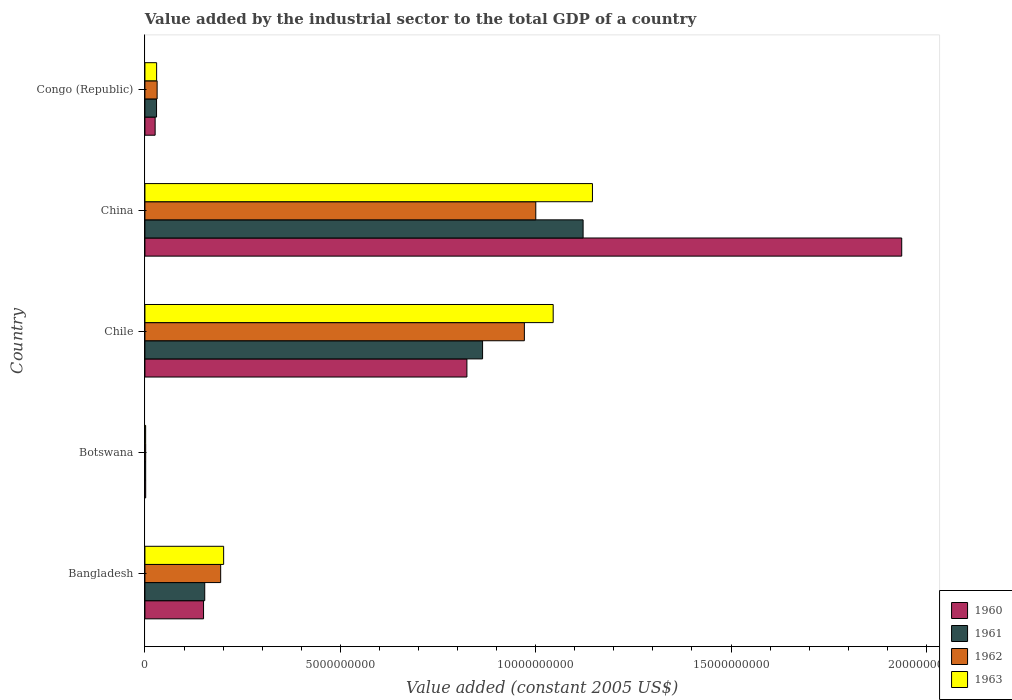Are the number of bars on each tick of the Y-axis equal?
Your response must be concise. Yes. What is the label of the 3rd group of bars from the top?
Offer a very short reply. Chile. What is the value added by the industrial sector in 1962 in China?
Make the answer very short. 1.00e+1. Across all countries, what is the maximum value added by the industrial sector in 1962?
Offer a very short reply. 1.00e+1. Across all countries, what is the minimum value added by the industrial sector in 1962?
Give a very brief answer. 1.98e+07. In which country was the value added by the industrial sector in 1960 maximum?
Your answer should be very brief. China. In which country was the value added by the industrial sector in 1962 minimum?
Give a very brief answer. Botswana. What is the total value added by the industrial sector in 1961 in the graph?
Offer a terse response. 2.17e+1. What is the difference between the value added by the industrial sector in 1961 in Bangladesh and that in Chile?
Ensure brevity in your answer.  -7.11e+09. What is the difference between the value added by the industrial sector in 1962 in Botswana and the value added by the industrial sector in 1963 in Bangladesh?
Offer a very short reply. -1.99e+09. What is the average value added by the industrial sector in 1963 per country?
Make the answer very short. 4.85e+09. What is the difference between the value added by the industrial sector in 1960 and value added by the industrial sector in 1963 in Botswana?
Provide a short and direct response. 1.27e+06. What is the ratio of the value added by the industrial sector in 1960 in Bangladesh to that in Chile?
Provide a succinct answer. 0.18. What is the difference between the highest and the second highest value added by the industrial sector in 1961?
Give a very brief answer. 2.57e+09. What is the difference between the highest and the lowest value added by the industrial sector in 1962?
Offer a terse response. 9.98e+09. What does the 1st bar from the top in Chile represents?
Keep it short and to the point. 1963. Are all the bars in the graph horizontal?
Make the answer very short. Yes. How many countries are there in the graph?
Offer a terse response. 5. How many legend labels are there?
Keep it short and to the point. 4. What is the title of the graph?
Your answer should be very brief. Value added by the industrial sector to the total GDP of a country. Does "1984" appear as one of the legend labels in the graph?
Your answer should be compact. No. What is the label or title of the X-axis?
Your answer should be very brief. Value added (constant 2005 US$). What is the label or title of the Y-axis?
Make the answer very short. Country. What is the Value added (constant 2005 US$) in 1960 in Bangladesh?
Give a very brief answer. 1.50e+09. What is the Value added (constant 2005 US$) of 1961 in Bangladesh?
Your answer should be very brief. 1.53e+09. What is the Value added (constant 2005 US$) of 1962 in Bangladesh?
Your answer should be compact. 1.94e+09. What is the Value added (constant 2005 US$) in 1963 in Bangladesh?
Provide a short and direct response. 2.01e+09. What is the Value added (constant 2005 US$) in 1960 in Botswana?
Make the answer very short. 1.96e+07. What is the Value added (constant 2005 US$) in 1961 in Botswana?
Provide a short and direct response. 1.92e+07. What is the Value added (constant 2005 US$) of 1962 in Botswana?
Make the answer very short. 1.98e+07. What is the Value added (constant 2005 US$) in 1963 in Botswana?
Ensure brevity in your answer.  1.83e+07. What is the Value added (constant 2005 US$) of 1960 in Chile?
Your answer should be compact. 8.24e+09. What is the Value added (constant 2005 US$) of 1961 in Chile?
Provide a succinct answer. 8.64e+09. What is the Value added (constant 2005 US$) in 1962 in Chile?
Your response must be concise. 9.71e+09. What is the Value added (constant 2005 US$) of 1963 in Chile?
Your response must be concise. 1.04e+1. What is the Value added (constant 2005 US$) in 1960 in China?
Offer a terse response. 1.94e+1. What is the Value added (constant 2005 US$) of 1961 in China?
Your answer should be compact. 1.12e+1. What is the Value added (constant 2005 US$) in 1962 in China?
Give a very brief answer. 1.00e+1. What is the Value added (constant 2005 US$) of 1963 in China?
Give a very brief answer. 1.15e+1. What is the Value added (constant 2005 US$) of 1960 in Congo (Republic)?
Your response must be concise. 2.61e+08. What is the Value added (constant 2005 US$) of 1961 in Congo (Republic)?
Your answer should be very brief. 2.98e+08. What is the Value added (constant 2005 US$) of 1962 in Congo (Republic)?
Keep it short and to the point. 3.12e+08. What is the Value added (constant 2005 US$) in 1963 in Congo (Republic)?
Keep it short and to the point. 3.00e+08. Across all countries, what is the maximum Value added (constant 2005 US$) in 1960?
Offer a terse response. 1.94e+1. Across all countries, what is the maximum Value added (constant 2005 US$) in 1961?
Offer a very short reply. 1.12e+1. Across all countries, what is the maximum Value added (constant 2005 US$) of 1962?
Ensure brevity in your answer.  1.00e+1. Across all countries, what is the maximum Value added (constant 2005 US$) in 1963?
Make the answer very short. 1.15e+1. Across all countries, what is the minimum Value added (constant 2005 US$) of 1960?
Your answer should be compact. 1.96e+07. Across all countries, what is the minimum Value added (constant 2005 US$) of 1961?
Keep it short and to the point. 1.92e+07. Across all countries, what is the minimum Value added (constant 2005 US$) of 1962?
Provide a short and direct response. 1.98e+07. Across all countries, what is the minimum Value added (constant 2005 US$) in 1963?
Your response must be concise. 1.83e+07. What is the total Value added (constant 2005 US$) of 1960 in the graph?
Your answer should be very brief. 2.94e+1. What is the total Value added (constant 2005 US$) in 1961 in the graph?
Provide a succinct answer. 2.17e+1. What is the total Value added (constant 2005 US$) in 1962 in the graph?
Provide a short and direct response. 2.20e+1. What is the total Value added (constant 2005 US$) of 1963 in the graph?
Offer a terse response. 2.42e+1. What is the difference between the Value added (constant 2005 US$) of 1960 in Bangladesh and that in Botswana?
Your answer should be very brief. 1.48e+09. What is the difference between the Value added (constant 2005 US$) in 1961 in Bangladesh and that in Botswana?
Make the answer very short. 1.51e+09. What is the difference between the Value added (constant 2005 US$) in 1962 in Bangladesh and that in Botswana?
Provide a short and direct response. 1.92e+09. What is the difference between the Value added (constant 2005 US$) of 1963 in Bangladesh and that in Botswana?
Give a very brief answer. 2.00e+09. What is the difference between the Value added (constant 2005 US$) in 1960 in Bangladesh and that in Chile?
Provide a short and direct response. -6.74e+09. What is the difference between the Value added (constant 2005 US$) of 1961 in Bangladesh and that in Chile?
Your answer should be very brief. -7.11e+09. What is the difference between the Value added (constant 2005 US$) of 1962 in Bangladesh and that in Chile?
Keep it short and to the point. -7.77e+09. What is the difference between the Value added (constant 2005 US$) in 1963 in Bangladesh and that in Chile?
Offer a very short reply. -8.43e+09. What is the difference between the Value added (constant 2005 US$) of 1960 in Bangladesh and that in China?
Make the answer very short. -1.79e+1. What is the difference between the Value added (constant 2005 US$) of 1961 in Bangladesh and that in China?
Offer a very short reply. -9.68e+09. What is the difference between the Value added (constant 2005 US$) in 1962 in Bangladesh and that in China?
Provide a succinct answer. -8.06e+09. What is the difference between the Value added (constant 2005 US$) in 1963 in Bangladesh and that in China?
Give a very brief answer. -9.44e+09. What is the difference between the Value added (constant 2005 US$) of 1960 in Bangladesh and that in Congo (Republic)?
Your answer should be compact. 1.24e+09. What is the difference between the Value added (constant 2005 US$) of 1961 in Bangladesh and that in Congo (Republic)?
Your response must be concise. 1.23e+09. What is the difference between the Value added (constant 2005 US$) in 1962 in Bangladesh and that in Congo (Republic)?
Your answer should be compact. 1.63e+09. What is the difference between the Value added (constant 2005 US$) of 1963 in Bangladesh and that in Congo (Republic)?
Your answer should be very brief. 1.71e+09. What is the difference between the Value added (constant 2005 US$) in 1960 in Botswana and that in Chile?
Provide a succinct answer. -8.22e+09. What is the difference between the Value added (constant 2005 US$) of 1961 in Botswana and that in Chile?
Provide a short and direct response. -8.62e+09. What is the difference between the Value added (constant 2005 US$) of 1962 in Botswana and that in Chile?
Provide a short and direct response. -9.69e+09. What is the difference between the Value added (constant 2005 US$) in 1963 in Botswana and that in Chile?
Your response must be concise. -1.04e+1. What is the difference between the Value added (constant 2005 US$) in 1960 in Botswana and that in China?
Make the answer very short. -1.93e+1. What is the difference between the Value added (constant 2005 US$) in 1961 in Botswana and that in China?
Provide a short and direct response. -1.12e+1. What is the difference between the Value added (constant 2005 US$) in 1962 in Botswana and that in China?
Ensure brevity in your answer.  -9.98e+09. What is the difference between the Value added (constant 2005 US$) of 1963 in Botswana and that in China?
Provide a succinct answer. -1.14e+1. What is the difference between the Value added (constant 2005 US$) of 1960 in Botswana and that in Congo (Republic)?
Provide a succinct answer. -2.42e+08. What is the difference between the Value added (constant 2005 US$) in 1961 in Botswana and that in Congo (Republic)?
Give a very brief answer. -2.78e+08. What is the difference between the Value added (constant 2005 US$) in 1962 in Botswana and that in Congo (Republic)?
Offer a terse response. -2.93e+08. What is the difference between the Value added (constant 2005 US$) of 1963 in Botswana and that in Congo (Republic)?
Offer a very short reply. -2.81e+08. What is the difference between the Value added (constant 2005 US$) in 1960 in Chile and that in China?
Offer a terse response. -1.11e+1. What is the difference between the Value added (constant 2005 US$) in 1961 in Chile and that in China?
Provide a succinct answer. -2.57e+09. What is the difference between the Value added (constant 2005 US$) in 1962 in Chile and that in China?
Offer a terse response. -2.92e+08. What is the difference between the Value added (constant 2005 US$) of 1963 in Chile and that in China?
Your answer should be very brief. -1.01e+09. What is the difference between the Value added (constant 2005 US$) in 1960 in Chile and that in Congo (Republic)?
Provide a succinct answer. 7.98e+09. What is the difference between the Value added (constant 2005 US$) of 1961 in Chile and that in Congo (Republic)?
Your answer should be very brief. 8.34e+09. What is the difference between the Value added (constant 2005 US$) of 1962 in Chile and that in Congo (Republic)?
Your response must be concise. 9.40e+09. What is the difference between the Value added (constant 2005 US$) of 1963 in Chile and that in Congo (Republic)?
Provide a succinct answer. 1.01e+1. What is the difference between the Value added (constant 2005 US$) in 1960 in China and that in Congo (Republic)?
Provide a succinct answer. 1.91e+1. What is the difference between the Value added (constant 2005 US$) in 1961 in China and that in Congo (Republic)?
Offer a terse response. 1.09e+1. What is the difference between the Value added (constant 2005 US$) of 1962 in China and that in Congo (Republic)?
Provide a succinct answer. 9.69e+09. What is the difference between the Value added (constant 2005 US$) of 1963 in China and that in Congo (Republic)?
Ensure brevity in your answer.  1.12e+1. What is the difference between the Value added (constant 2005 US$) of 1960 in Bangladesh and the Value added (constant 2005 US$) of 1961 in Botswana?
Give a very brief answer. 1.48e+09. What is the difference between the Value added (constant 2005 US$) in 1960 in Bangladesh and the Value added (constant 2005 US$) in 1962 in Botswana?
Provide a short and direct response. 1.48e+09. What is the difference between the Value added (constant 2005 US$) in 1960 in Bangladesh and the Value added (constant 2005 US$) in 1963 in Botswana?
Offer a very short reply. 1.48e+09. What is the difference between the Value added (constant 2005 US$) in 1961 in Bangladesh and the Value added (constant 2005 US$) in 1962 in Botswana?
Your answer should be compact. 1.51e+09. What is the difference between the Value added (constant 2005 US$) in 1961 in Bangladesh and the Value added (constant 2005 US$) in 1963 in Botswana?
Ensure brevity in your answer.  1.51e+09. What is the difference between the Value added (constant 2005 US$) of 1962 in Bangladesh and the Value added (constant 2005 US$) of 1963 in Botswana?
Your answer should be compact. 1.92e+09. What is the difference between the Value added (constant 2005 US$) in 1960 in Bangladesh and the Value added (constant 2005 US$) in 1961 in Chile?
Your answer should be very brief. -7.14e+09. What is the difference between the Value added (constant 2005 US$) in 1960 in Bangladesh and the Value added (constant 2005 US$) in 1962 in Chile?
Offer a terse response. -8.21e+09. What is the difference between the Value added (constant 2005 US$) in 1960 in Bangladesh and the Value added (constant 2005 US$) in 1963 in Chile?
Provide a succinct answer. -8.95e+09. What is the difference between the Value added (constant 2005 US$) in 1961 in Bangladesh and the Value added (constant 2005 US$) in 1962 in Chile?
Provide a succinct answer. -8.18e+09. What is the difference between the Value added (constant 2005 US$) in 1961 in Bangladesh and the Value added (constant 2005 US$) in 1963 in Chile?
Ensure brevity in your answer.  -8.92e+09. What is the difference between the Value added (constant 2005 US$) in 1962 in Bangladesh and the Value added (constant 2005 US$) in 1963 in Chile?
Keep it short and to the point. -8.51e+09. What is the difference between the Value added (constant 2005 US$) of 1960 in Bangladesh and the Value added (constant 2005 US$) of 1961 in China?
Give a very brief answer. -9.71e+09. What is the difference between the Value added (constant 2005 US$) of 1960 in Bangladesh and the Value added (constant 2005 US$) of 1962 in China?
Make the answer very short. -8.50e+09. What is the difference between the Value added (constant 2005 US$) of 1960 in Bangladesh and the Value added (constant 2005 US$) of 1963 in China?
Offer a terse response. -9.95e+09. What is the difference between the Value added (constant 2005 US$) in 1961 in Bangladesh and the Value added (constant 2005 US$) in 1962 in China?
Ensure brevity in your answer.  -8.47e+09. What is the difference between the Value added (constant 2005 US$) of 1961 in Bangladesh and the Value added (constant 2005 US$) of 1963 in China?
Give a very brief answer. -9.92e+09. What is the difference between the Value added (constant 2005 US$) in 1962 in Bangladesh and the Value added (constant 2005 US$) in 1963 in China?
Keep it short and to the point. -9.51e+09. What is the difference between the Value added (constant 2005 US$) in 1960 in Bangladesh and the Value added (constant 2005 US$) in 1961 in Congo (Republic)?
Your answer should be very brief. 1.20e+09. What is the difference between the Value added (constant 2005 US$) of 1960 in Bangladesh and the Value added (constant 2005 US$) of 1962 in Congo (Republic)?
Your answer should be compact. 1.19e+09. What is the difference between the Value added (constant 2005 US$) of 1960 in Bangladesh and the Value added (constant 2005 US$) of 1963 in Congo (Republic)?
Your response must be concise. 1.20e+09. What is the difference between the Value added (constant 2005 US$) of 1961 in Bangladesh and the Value added (constant 2005 US$) of 1962 in Congo (Republic)?
Your answer should be compact. 1.22e+09. What is the difference between the Value added (constant 2005 US$) of 1961 in Bangladesh and the Value added (constant 2005 US$) of 1963 in Congo (Republic)?
Give a very brief answer. 1.23e+09. What is the difference between the Value added (constant 2005 US$) in 1962 in Bangladesh and the Value added (constant 2005 US$) in 1963 in Congo (Republic)?
Keep it short and to the point. 1.64e+09. What is the difference between the Value added (constant 2005 US$) of 1960 in Botswana and the Value added (constant 2005 US$) of 1961 in Chile?
Your answer should be compact. -8.62e+09. What is the difference between the Value added (constant 2005 US$) in 1960 in Botswana and the Value added (constant 2005 US$) in 1962 in Chile?
Your answer should be compact. -9.69e+09. What is the difference between the Value added (constant 2005 US$) in 1960 in Botswana and the Value added (constant 2005 US$) in 1963 in Chile?
Make the answer very short. -1.04e+1. What is the difference between the Value added (constant 2005 US$) in 1961 in Botswana and the Value added (constant 2005 US$) in 1962 in Chile?
Ensure brevity in your answer.  -9.69e+09. What is the difference between the Value added (constant 2005 US$) of 1961 in Botswana and the Value added (constant 2005 US$) of 1963 in Chile?
Your answer should be very brief. -1.04e+1. What is the difference between the Value added (constant 2005 US$) of 1962 in Botswana and the Value added (constant 2005 US$) of 1963 in Chile?
Give a very brief answer. -1.04e+1. What is the difference between the Value added (constant 2005 US$) in 1960 in Botswana and the Value added (constant 2005 US$) in 1961 in China?
Offer a very short reply. -1.12e+1. What is the difference between the Value added (constant 2005 US$) of 1960 in Botswana and the Value added (constant 2005 US$) of 1962 in China?
Provide a succinct answer. -9.98e+09. What is the difference between the Value added (constant 2005 US$) of 1960 in Botswana and the Value added (constant 2005 US$) of 1963 in China?
Offer a very short reply. -1.14e+1. What is the difference between the Value added (constant 2005 US$) of 1961 in Botswana and the Value added (constant 2005 US$) of 1962 in China?
Your answer should be very brief. -9.98e+09. What is the difference between the Value added (constant 2005 US$) in 1961 in Botswana and the Value added (constant 2005 US$) in 1963 in China?
Offer a terse response. -1.14e+1. What is the difference between the Value added (constant 2005 US$) in 1962 in Botswana and the Value added (constant 2005 US$) in 1963 in China?
Give a very brief answer. -1.14e+1. What is the difference between the Value added (constant 2005 US$) in 1960 in Botswana and the Value added (constant 2005 US$) in 1961 in Congo (Republic)?
Provide a short and direct response. -2.78e+08. What is the difference between the Value added (constant 2005 US$) of 1960 in Botswana and the Value added (constant 2005 US$) of 1962 in Congo (Republic)?
Your answer should be very brief. -2.93e+08. What is the difference between the Value added (constant 2005 US$) of 1960 in Botswana and the Value added (constant 2005 US$) of 1963 in Congo (Republic)?
Provide a succinct answer. -2.80e+08. What is the difference between the Value added (constant 2005 US$) of 1961 in Botswana and the Value added (constant 2005 US$) of 1962 in Congo (Republic)?
Keep it short and to the point. -2.93e+08. What is the difference between the Value added (constant 2005 US$) of 1961 in Botswana and the Value added (constant 2005 US$) of 1963 in Congo (Republic)?
Your response must be concise. -2.81e+08. What is the difference between the Value added (constant 2005 US$) of 1962 in Botswana and the Value added (constant 2005 US$) of 1963 in Congo (Republic)?
Your response must be concise. -2.80e+08. What is the difference between the Value added (constant 2005 US$) of 1960 in Chile and the Value added (constant 2005 US$) of 1961 in China?
Make the answer very short. -2.97e+09. What is the difference between the Value added (constant 2005 US$) in 1960 in Chile and the Value added (constant 2005 US$) in 1962 in China?
Keep it short and to the point. -1.76e+09. What is the difference between the Value added (constant 2005 US$) in 1960 in Chile and the Value added (constant 2005 US$) in 1963 in China?
Your answer should be very brief. -3.21e+09. What is the difference between the Value added (constant 2005 US$) in 1961 in Chile and the Value added (constant 2005 US$) in 1962 in China?
Your answer should be compact. -1.36e+09. What is the difference between the Value added (constant 2005 US$) of 1961 in Chile and the Value added (constant 2005 US$) of 1963 in China?
Your response must be concise. -2.81e+09. What is the difference between the Value added (constant 2005 US$) of 1962 in Chile and the Value added (constant 2005 US$) of 1963 in China?
Give a very brief answer. -1.74e+09. What is the difference between the Value added (constant 2005 US$) of 1960 in Chile and the Value added (constant 2005 US$) of 1961 in Congo (Republic)?
Keep it short and to the point. 7.94e+09. What is the difference between the Value added (constant 2005 US$) in 1960 in Chile and the Value added (constant 2005 US$) in 1962 in Congo (Republic)?
Offer a very short reply. 7.93e+09. What is the difference between the Value added (constant 2005 US$) in 1960 in Chile and the Value added (constant 2005 US$) in 1963 in Congo (Republic)?
Provide a succinct answer. 7.94e+09. What is the difference between the Value added (constant 2005 US$) in 1961 in Chile and the Value added (constant 2005 US$) in 1962 in Congo (Republic)?
Ensure brevity in your answer.  8.33e+09. What is the difference between the Value added (constant 2005 US$) of 1961 in Chile and the Value added (constant 2005 US$) of 1963 in Congo (Republic)?
Make the answer very short. 8.34e+09. What is the difference between the Value added (constant 2005 US$) in 1962 in Chile and the Value added (constant 2005 US$) in 1963 in Congo (Republic)?
Keep it short and to the point. 9.41e+09. What is the difference between the Value added (constant 2005 US$) in 1960 in China and the Value added (constant 2005 US$) in 1961 in Congo (Republic)?
Make the answer very short. 1.91e+1. What is the difference between the Value added (constant 2005 US$) of 1960 in China and the Value added (constant 2005 US$) of 1962 in Congo (Republic)?
Provide a succinct answer. 1.91e+1. What is the difference between the Value added (constant 2005 US$) of 1960 in China and the Value added (constant 2005 US$) of 1963 in Congo (Republic)?
Your answer should be very brief. 1.91e+1. What is the difference between the Value added (constant 2005 US$) of 1961 in China and the Value added (constant 2005 US$) of 1962 in Congo (Republic)?
Give a very brief answer. 1.09e+1. What is the difference between the Value added (constant 2005 US$) of 1961 in China and the Value added (constant 2005 US$) of 1963 in Congo (Republic)?
Make the answer very short. 1.09e+1. What is the difference between the Value added (constant 2005 US$) of 1962 in China and the Value added (constant 2005 US$) of 1963 in Congo (Republic)?
Keep it short and to the point. 9.70e+09. What is the average Value added (constant 2005 US$) of 1960 per country?
Make the answer very short. 5.88e+09. What is the average Value added (constant 2005 US$) of 1961 per country?
Make the answer very short. 4.34e+09. What is the average Value added (constant 2005 US$) of 1962 per country?
Your answer should be very brief. 4.40e+09. What is the average Value added (constant 2005 US$) of 1963 per country?
Make the answer very short. 4.85e+09. What is the difference between the Value added (constant 2005 US$) of 1960 and Value added (constant 2005 US$) of 1961 in Bangladesh?
Give a very brief answer. -3.05e+07. What is the difference between the Value added (constant 2005 US$) in 1960 and Value added (constant 2005 US$) in 1962 in Bangladesh?
Your response must be concise. -4.38e+08. What is the difference between the Value added (constant 2005 US$) of 1960 and Value added (constant 2005 US$) of 1963 in Bangladesh?
Make the answer very short. -5.14e+08. What is the difference between the Value added (constant 2005 US$) in 1961 and Value added (constant 2005 US$) in 1962 in Bangladesh?
Ensure brevity in your answer.  -4.08e+08. What is the difference between the Value added (constant 2005 US$) in 1961 and Value added (constant 2005 US$) in 1963 in Bangladesh?
Offer a very short reply. -4.84e+08. What is the difference between the Value added (constant 2005 US$) in 1962 and Value added (constant 2005 US$) in 1963 in Bangladesh?
Your answer should be compact. -7.60e+07. What is the difference between the Value added (constant 2005 US$) of 1960 and Value added (constant 2005 US$) of 1961 in Botswana?
Provide a succinct answer. 4.24e+05. What is the difference between the Value added (constant 2005 US$) in 1960 and Value added (constant 2005 US$) in 1962 in Botswana?
Your answer should be very brief. -2.12e+05. What is the difference between the Value added (constant 2005 US$) in 1960 and Value added (constant 2005 US$) in 1963 in Botswana?
Offer a terse response. 1.27e+06. What is the difference between the Value added (constant 2005 US$) in 1961 and Value added (constant 2005 US$) in 1962 in Botswana?
Make the answer very short. -6.36e+05. What is the difference between the Value added (constant 2005 US$) in 1961 and Value added (constant 2005 US$) in 1963 in Botswana?
Provide a succinct answer. 8.48e+05. What is the difference between the Value added (constant 2005 US$) in 1962 and Value added (constant 2005 US$) in 1963 in Botswana?
Your answer should be compact. 1.48e+06. What is the difference between the Value added (constant 2005 US$) of 1960 and Value added (constant 2005 US$) of 1961 in Chile?
Offer a very short reply. -4.01e+08. What is the difference between the Value added (constant 2005 US$) of 1960 and Value added (constant 2005 US$) of 1962 in Chile?
Your response must be concise. -1.47e+09. What is the difference between the Value added (constant 2005 US$) in 1960 and Value added (constant 2005 US$) in 1963 in Chile?
Make the answer very short. -2.21e+09. What is the difference between the Value added (constant 2005 US$) in 1961 and Value added (constant 2005 US$) in 1962 in Chile?
Keep it short and to the point. -1.07e+09. What is the difference between the Value added (constant 2005 US$) in 1961 and Value added (constant 2005 US$) in 1963 in Chile?
Provide a short and direct response. -1.81e+09. What is the difference between the Value added (constant 2005 US$) of 1962 and Value added (constant 2005 US$) of 1963 in Chile?
Provide a succinct answer. -7.37e+08. What is the difference between the Value added (constant 2005 US$) of 1960 and Value added (constant 2005 US$) of 1961 in China?
Give a very brief answer. 8.15e+09. What is the difference between the Value added (constant 2005 US$) in 1960 and Value added (constant 2005 US$) in 1962 in China?
Offer a very short reply. 9.36e+09. What is the difference between the Value added (constant 2005 US$) of 1960 and Value added (constant 2005 US$) of 1963 in China?
Ensure brevity in your answer.  7.91e+09. What is the difference between the Value added (constant 2005 US$) of 1961 and Value added (constant 2005 US$) of 1962 in China?
Give a very brief answer. 1.21e+09. What is the difference between the Value added (constant 2005 US$) of 1961 and Value added (constant 2005 US$) of 1963 in China?
Provide a succinct answer. -2.39e+08. What is the difference between the Value added (constant 2005 US$) in 1962 and Value added (constant 2005 US$) in 1963 in China?
Make the answer very short. -1.45e+09. What is the difference between the Value added (constant 2005 US$) in 1960 and Value added (constant 2005 US$) in 1961 in Congo (Republic)?
Provide a short and direct response. -3.63e+07. What is the difference between the Value added (constant 2005 US$) in 1960 and Value added (constant 2005 US$) in 1962 in Congo (Republic)?
Offer a very short reply. -5.10e+07. What is the difference between the Value added (constant 2005 US$) of 1960 and Value added (constant 2005 US$) of 1963 in Congo (Republic)?
Make the answer very short. -3.84e+07. What is the difference between the Value added (constant 2005 US$) of 1961 and Value added (constant 2005 US$) of 1962 in Congo (Republic)?
Make the answer very short. -1.47e+07. What is the difference between the Value added (constant 2005 US$) in 1961 and Value added (constant 2005 US$) in 1963 in Congo (Republic)?
Give a very brief answer. -2.10e+06. What is the difference between the Value added (constant 2005 US$) in 1962 and Value added (constant 2005 US$) in 1963 in Congo (Republic)?
Provide a short and direct response. 1.26e+07. What is the ratio of the Value added (constant 2005 US$) in 1960 in Bangladesh to that in Botswana?
Your response must be concise. 76.48. What is the ratio of the Value added (constant 2005 US$) of 1961 in Bangladesh to that in Botswana?
Your response must be concise. 79.76. What is the ratio of the Value added (constant 2005 US$) of 1962 in Bangladesh to that in Botswana?
Make the answer very short. 97.78. What is the ratio of the Value added (constant 2005 US$) in 1963 in Bangladesh to that in Botswana?
Provide a succinct answer. 109.83. What is the ratio of the Value added (constant 2005 US$) in 1960 in Bangladesh to that in Chile?
Give a very brief answer. 0.18. What is the ratio of the Value added (constant 2005 US$) of 1961 in Bangladesh to that in Chile?
Give a very brief answer. 0.18. What is the ratio of the Value added (constant 2005 US$) in 1962 in Bangladesh to that in Chile?
Make the answer very short. 0.2. What is the ratio of the Value added (constant 2005 US$) of 1963 in Bangladesh to that in Chile?
Your answer should be compact. 0.19. What is the ratio of the Value added (constant 2005 US$) in 1960 in Bangladesh to that in China?
Keep it short and to the point. 0.08. What is the ratio of the Value added (constant 2005 US$) in 1961 in Bangladesh to that in China?
Offer a terse response. 0.14. What is the ratio of the Value added (constant 2005 US$) of 1962 in Bangladesh to that in China?
Your response must be concise. 0.19. What is the ratio of the Value added (constant 2005 US$) in 1963 in Bangladesh to that in China?
Your response must be concise. 0.18. What is the ratio of the Value added (constant 2005 US$) in 1960 in Bangladesh to that in Congo (Republic)?
Make the answer very short. 5.74. What is the ratio of the Value added (constant 2005 US$) of 1961 in Bangladesh to that in Congo (Republic)?
Your response must be concise. 5.14. What is the ratio of the Value added (constant 2005 US$) in 1962 in Bangladesh to that in Congo (Republic)?
Give a very brief answer. 6.21. What is the ratio of the Value added (constant 2005 US$) in 1963 in Bangladesh to that in Congo (Republic)?
Provide a succinct answer. 6.72. What is the ratio of the Value added (constant 2005 US$) of 1960 in Botswana to that in Chile?
Offer a terse response. 0. What is the ratio of the Value added (constant 2005 US$) in 1961 in Botswana to that in Chile?
Your answer should be compact. 0. What is the ratio of the Value added (constant 2005 US$) in 1962 in Botswana to that in Chile?
Your answer should be compact. 0. What is the ratio of the Value added (constant 2005 US$) in 1963 in Botswana to that in Chile?
Provide a short and direct response. 0. What is the ratio of the Value added (constant 2005 US$) of 1960 in Botswana to that in China?
Your answer should be very brief. 0. What is the ratio of the Value added (constant 2005 US$) in 1961 in Botswana to that in China?
Offer a terse response. 0. What is the ratio of the Value added (constant 2005 US$) in 1962 in Botswana to that in China?
Offer a very short reply. 0. What is the ratio of the Value added (constant 2005 US$) in 1963 in Botswana to that in China?
Offer a terse response. 0. What is the ratio of the Value added (constant 2005 US$) of 1960 in Botswana to that in Congo (Republic)?
Give a very brief answer. 0.07. What is the ratio of the Value added (constant 2005 US$) of 1961 in Botswana to that in Congo (Republic)?
Your response must be concise. 0.06. What is the ratio of the Value added (constant 2005 US$) of 1962 in Botswana to that in Congo (Republic)?
Offer a very short reply. 0.06. What is the ratio of the Value added (constant 2005 US$) in 1963 in Botswana to that in Congo (Republic)?
Ensure brevity in your answer.  0.06. What is the ratio of the Value added (constant 2005 US$) of 1960 in Chile to that in China?
Offer a very short reply. 0.43. What is the ratio of the Value added (constant 2005 US$) of 1961 in Chile to that in China?
Give a very brief answer. 0.77. What is the ratio of the Value added (constant 2005 US$) of 1962 in Chile to that in China?
Your response must be concise. 0.97. What is the ratio of the Value added (constant 2005 US$) of 1963 in Chile to that in China?
Offer a very short reply. 0.91. What is the ratio of the Value added (constant 2005 US$) in 1960 in Chile to that in Congo (Republic)?
Give a very brief answer. 31.52. What is the ratio of the Value added (constant 2005 US$) in 1961 in Chile to that in Congo (Republic)?
Offer a very short reply. 29.03. What is the ratio of the Value added (constant 2005 US$) in 1962 in Chile to that in Congo (Republic)?
Your answer should be very brief. 31.09. What is the ratio of the Value added (constant 2005 US$) in 1963 in Chile to that in Congo (Republic)?
Offer a terse response. 34.85. What is the ratio of the Value added (constant 2005 US$) in 1960 in China to that in Congo (Republic)?
Your response must be concise. 74.09. What is the ratio of the Value added (constant 2005 US$) in 1961 in China to that in Congo (Republic)?
Provide a succinct answer. 37.67. What is the ratio of the Value added (constant 2005 US$) of 1962 in China to that in Congo (Republic)?
Your answer should be compact. 32.02. What is the ratio of the Value added (constant 2005 US$) of 1963 in China to that in Congo (Republic)?
Your answer should be very brief. 38.21. What is the difference between the highest and the second highest Value added (constant 2005 US$) in 1960?
Your answer should be compact. 1.11e+1. What is the difference between the highest and the second highest Value added (constant 2005 US$) in 1961?
Make the answer very short. 2.57e+09. What is the difference between the highest and the second highest Value added (constant 2005 US$) of 1962?
Ensure brevity in your answer.  2.92e+08. What is the difference between the highest and the second highest Value added (constant 2005 US$) in 1963?
Ensure brevity in your answer.  1.01e+09. What is the difference between the highest and the lowest Value added (constant 2005 US$) in 1960?
Provide a succinct answer. 1.93e+1. What is the difference between the highest and the lowest Value added (constant 2005 US$) of 1961?
Your answer should be very brief. 1.12e+1. What is the difference between the highest and the lowest Value added (constant 2005 US$) of 1962?
Your answer should be very brief. 9.98e+09. What is the difference between the highest and the lowest Value added (constant 2005 US$) of 1963?
Your answer should be compact. 1.14e+1. 